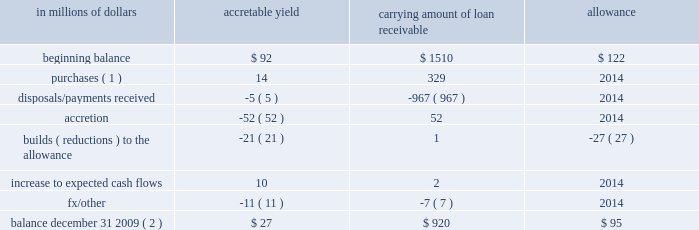In addition , included in the loan table are purchased distressed loans , which are loans that have evidenced significant credit deterioration subsequent to origination but prior to acquisition by citigroup .
In accordance with sop 03-3 , the difference between the total expected cash flows for these loans and the initial recorded investments is recognized in income over the life of the loans using a level yield .
Accordingly , these loans have been excluded from the impaired loan information presented above .
In addition , per sop 03-3 , subsequent decreases to the expected cash flows for a purchased distressed loan require a build of an allowance so the loan retains its level yield .
However , increases in the expected cash flows are first recognized as a reduction of any previously established allowance and then recognized as income prospectively over the remaining life of the loan by increasing the loan 2019s level yield .
Where the expected cash flows cannot be reliably estimated , the purchased distressed loan is accounted for under the cost recovery method .
The carrying amount of the purchased distressed loan portfolio at december 31 , 2009 was $ 825 million net of an allowance of $ 95 million .
The changes in the accretable yield , related allowance and carrying amount net of accretable yield for 2009 are as follows : in millions of dollars accretable carrying amount of loan receivable allowance .
( 1 ) the balance reported in the column 201ccarrying amount of loan receivable 201d consists of $ 87 million of purchased loans accounted for under the level-yield method and $ 242 million under the cost-recovery method .
These balances represent the fair value of these loans at their acquisition date .
The related total expected cash flows for the level-yield loans were $ 101 million at their acquisition dates .
( 2 ) the balance reported in the column 201ccarrying amount of loan receivable 201d consists of $ 561 million of loans accounted for under the level-yield method and $ 359 million accounted for under the cost-recovery method. .
What is the percent of the purchased loans accounted for under the level-yield method included in the carrying amount of loan receivable net of purchased loans accounted for under the under the cost-recovery method? 
Computations: (87 / (920 - 242))
Answer: 0.12832. In addition , included in the loan table are purchased distressed loans , which are loans that have evidenced significant credit deterioration subsequent to origination but prior to acquisition by citigroup .
In accordance with sop 03-3 , the difference between the total expected cash flows for these loans and the initial recorded investments is recognized in income over the life of the loans using a level yield .
Accordingly , these loans have been excluded from the impaired loan information presented above .
In addition , per sop 03-3 , subsequent decreases to the expected cash flows for a purchased distressed loan require a build of an allowance so the loan retains its level yield .
However , increases in the expected cash flows are first recognized as a reduction of any previously established allowance and then recognized as income prospectively over the remaining life of the loan by increasing the loan 2019s level yield .
Where the expected cash flows cannot be reliably estimated , the purchased distressed loan is accounted for under the cost recovery method .
The carrying amount of the purchased distressed loan portfolio at december 31 , 2009 was $ 825 million net of an allowance of $ 95 million .
The changes in the accretable yield , related allowance and carrying amount net of accretable yield for 2009 are as follows : in millions of dollars accretable carrying amount of loan receivable allowance .
( 1 ) the balance reported in the column 201ccarrying amount of loan receivable 201d consists of $ 87 million of purchased loans accounted for under the level-yield method and $ 242 million under the cost-recovery method .
These balances represent the fair value of these loans at their acquisition date .
The related total expected cash flows for the level-yield loans were $ 101 million at their acquisition dates .
( 2 ) the balance reported in the column 201ccarrying amount of loan receivable 201d consists of $ 561 million of loans accounted for under the level-yield method and $ 359 million accounted for under the cost-recovery method. .
In 2009 what was the percent of the purchases included in the total carrying amount of loan receivable? 
Computations: (329 / 920)
Answer: 0.35761. 